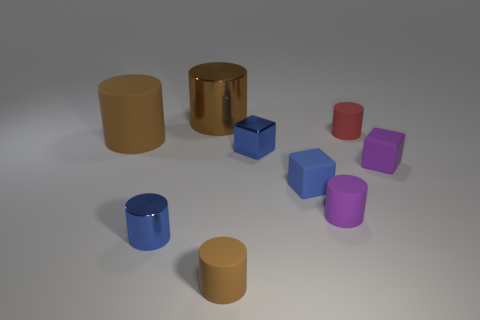Subtract all tiny rubber blocks. How many blocks are left? 1 Add 1 blue cylinders. How many objects exist? 10 Subtract all red cylinders. How many cylinders are left? 5 Subtract all gray blocks. How many brown cylinders are left? 3 Subtract all cylinders. How many objects are left? 3 Subtract 3 cylinders. How many cylinders are left? 3 Subtract 0 yellow blocks. How many objects are left? 9 Subtract all purple cylinders. Subtract all cyan spheres. How many cylinders are left? 5 Subtract all matte things. Subtract all large brown things. How many objects are left? 1 Add 1 small purple matte blocks. How many small purple matte blocks are left? 2 